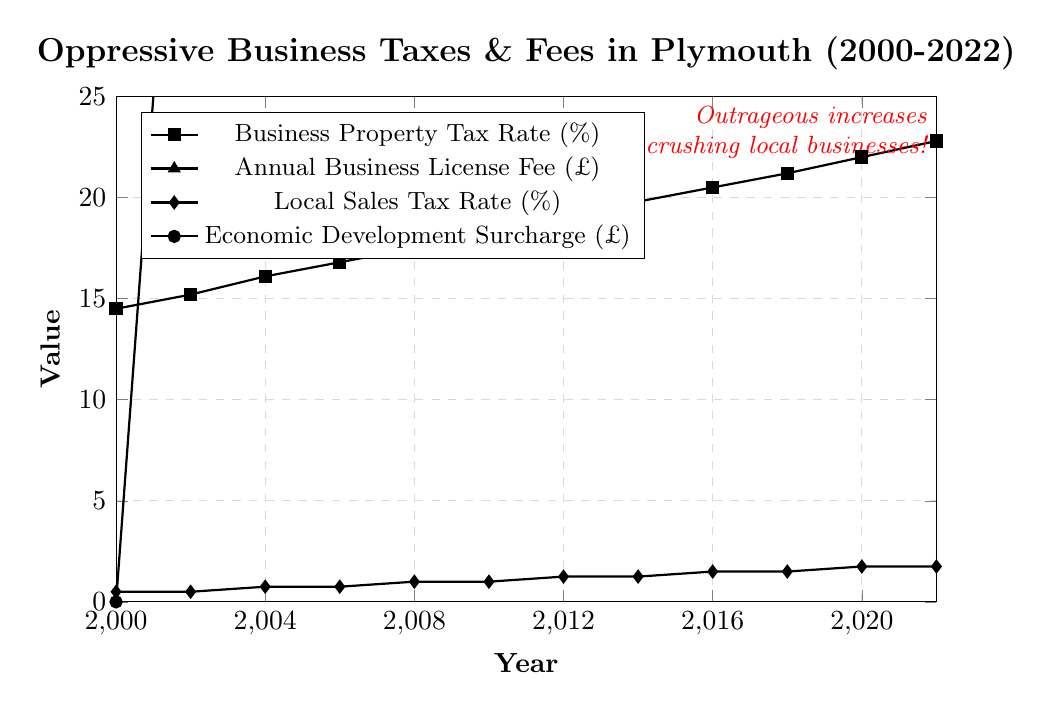What's the approximate increase in the Business Property Tax Rate from 2000 to 2022? In 2000, the Business Property Tax Rate was 14.5%. In 2022, it increased to 22.8%. The difference is calculated as 22.8 - 14.5 = 8.3%.
Answer: 8.3% By how much did the Annual Business License Fee increase from 2002 to 2014? In 2002, the Annual Business License Fee was £175, and in 2014, it was £325. The difference is 325 - 175 = £150.
Answer: £150 Which tax or fee saw the highest overall increase between 2000 and 2022? We need to calculate the increase for each tax or fee from 2000 to 2022. 
- Business Property Tax Rate: 22.8 - 14.5 = 8.3%
- Annual Business License Fee: 425 - 150 = £275
- Local Sales Tax Rate: 1.75 - 0.5 = 1.25%
- Economic Development Surcharge: 300 - 0 = £300
The Economic Development Surcharge experienced the highest increase of £300.
Answer: Economic Development Surcharge What is the average Local Sales Tax Rate between 2010 and 2022? Values are: 1.0 (2010), 1.25 (2012), 1.25 (2014), 1.5 (2016), 1.5 (2018), 1.75 (2020), 1.75 (2022). Sum these values: 1.0 + 1.25 + 1.25 + 1.5 + 1.5 + 1.75 + 1.75 = 9. Total count is 7. The average is 9 / 7 ≈ 1.29%.
Answer: 1.29% In what year did the Economic Development Surcharge first appear, and what was its initial value? The Economic Development Surcharge first appeared in 2002 with an initial value of £50.
Answer: 2002, £50 Between which consecutive years did the Annual Business License Fee experience the largest increase? We compare the increases between consecutive years:
- 2000-2002: 175 - 150 = £25
- 2002-2004: 200 - 175 = £25
- 2004-2006: 225 - 200 = £25
- 2006-2008: 250 - 225 = £25
- 2008-2010: 275 - 250 = £25
- 2010-2012: 300 - 275 = £25
- 2012-2014: 325 - 300 = £25
- 2014-2016: 350 - 325 = £25
- 2016-2018: 375 - 350 = £25
- 2018-2020: 400 - 375 = £25
- 2020-2022: 425 - 400 = £25
All increases are £25, so the largest increase is consistent across all periods.
Answer: 2000-2002, 2002-2004, 2004-2006, 2006-2008, 2008-2010, 2010-2012, 2012-2014, 2014-2016, 2016-2018, 2018-2020, 2020-2022 How many pounds does the Economic Development Surcharge increase every two years on average? Values at 2-year intervals: £0 (2000), £50 (2002), £75 (2004), £100 (2006), £125 (2008), £150 (2010), £175 (2012), £200 (2014), £225 (2016), £250 (2018), £275 (2020), £300 (2022). 
Total increase is £300 over 22 years, which gives an average increase every two years: 300 / 11 ≈ £27.27.
Answer: £27.27 